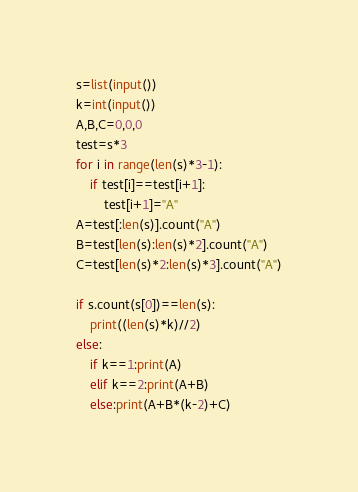<code> <loc_0><loc_0><loc_500><loc_500><_Python_>s=list(input())
k=int(input())
A,B,C=0,0,0
test=s*3
for i in range(len(s)*3-1):
    if test[i]==test[i+1]:
        test[i+1]="A"
A=test[:len(s)].count("A")
B=test[len(s):len(s)*2].count("A")
C=test[len(s)*2:len(s)*3].count("A")

if s.count(s[0])==len(s):
    print((len(s)*k)//2)
else:
    if k==1:print(A)
    elif k==2:print(A+B)
    else:print(A+B*(k-2)+C)</code> 